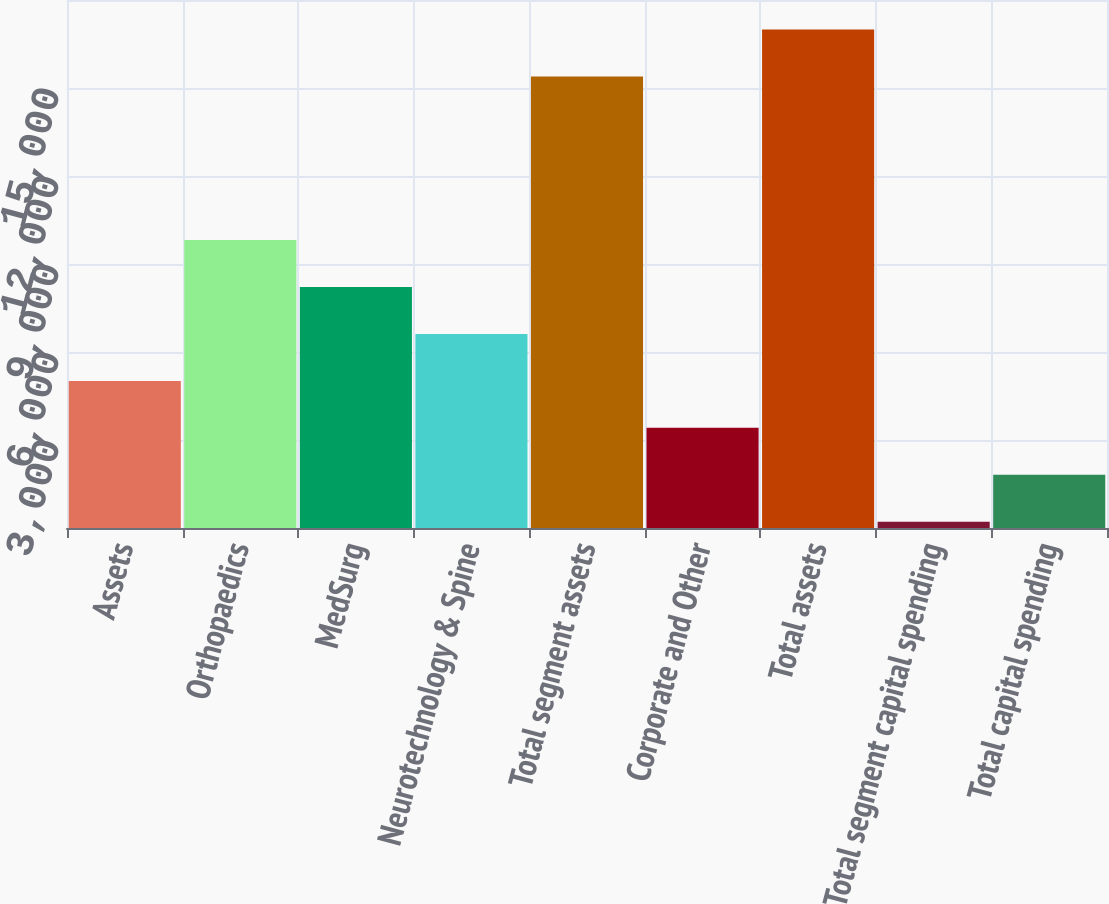Convert chart. <chart><loc_0><loc_0><loc_500><loc_500><bar_chart><fcel>Assets<fcel>Orthopaedics<fcel>MedSurg<fcel>Neurotechnology & Spine<fcel>Total segment assets<fcel>Corporate and Other<fcel>Total assets<fcel>Total segment capital spending<fcel>Total capital spending<nl><fcel>5015.3<fcel>9818.6<fcel>8217.5<fcel>6616.4<fcel>15394<fcel>3414.2<fcel>16995.1<fcel>212<fcel>1813.1<nl></chart> 